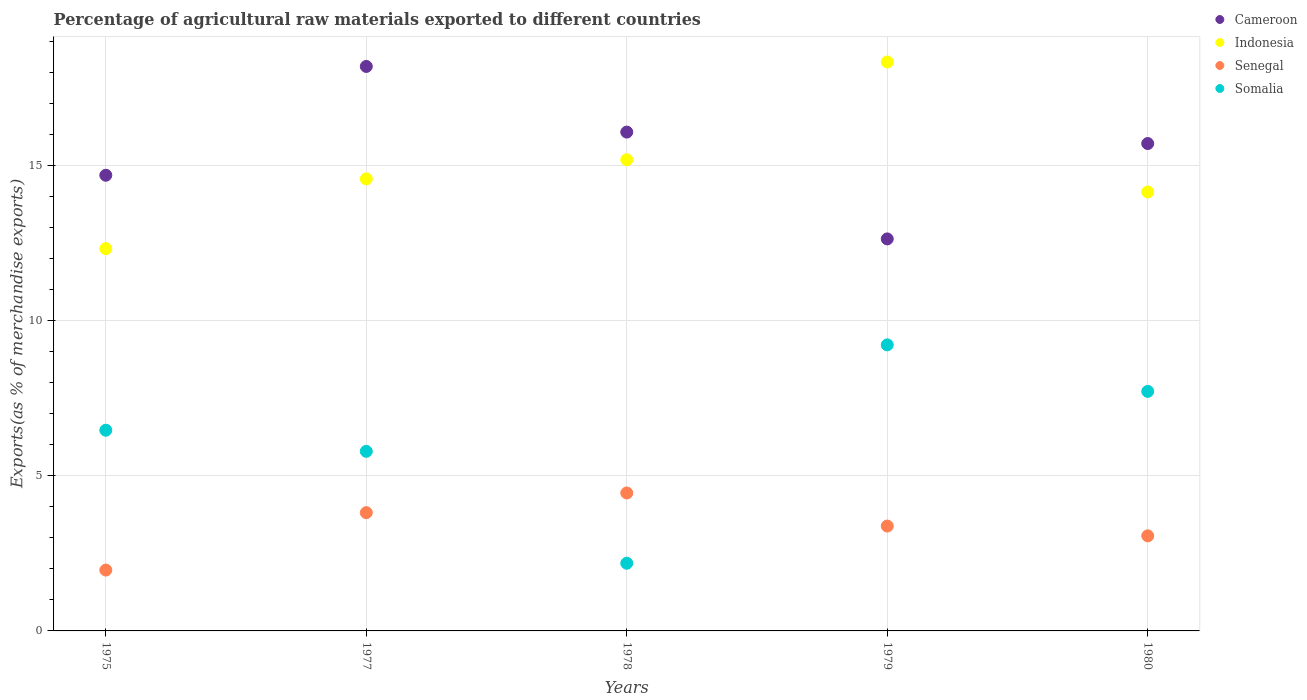What is the percentage of exports to different countries in Cameroon in 1979?
Make the answer very short. 12.63. Across all years, what is the maximum percentage of exports to different countries in Cameroon?
Offer a terse response. 18.18. Across all years, what is the minimum percentage of exports to different countries in Indonesia?
Offer a very short reply. 12.31. In which year was the percentage of exports to different countries in Cameroon maximum?
Your answer should be very brief. 1977. In which year was the percentage of exports to different countries in Indonesia minimum?
Keep it short and to the point. 1975. What is the total percentage of exports to different countries in Somalia in the graph?
Your answer should be compact. 31.36. What is the difference between the percentage of exports to different countries in Somalia in 1977 and that in 1980?
Your answer should be very brief. -1.93. What is the difference between the percentage of exports to different countries in Cameroon in 1979 and the percentage of exports to different countries in Indonesia in 1980?
Provide a short and direct response. -1.51. What is the average percentage of exports to different countries in Indonesia per year?
Provide a succinct answer. 14.9. In the year 1975, what is the difference between the percentage of exports to different countries in Cameroon and percentage of exports to different countries in Somalia?
Offer a very short reply. 8.21. What is the ratio of the percentage of exports to different countries in Senegal in 1977 to that in 1978?
Provide a succinct answer. 0.86. Is the difference between the percentage of exports to different countries in Cameroon in 1977 and 1978 greater than the difference between the percentage of exports to different countries in Somalia in 1977 and 1978?
Provide a short and direct response. No. What is the difference between the highest and the second highest percentage of exports to different countries in Somalia?
Keep it short and to the point. 1.5. What is the difference between the highest and the lowest percentage of exports to different countries in Somalia?
Offer a terse response. 7.03. In how many years, is the percentage of exports to different countries in Senegal greater than the average percentage of exports to different countries in Senegal taken over all years?
Ensure brevity in your answer.  3. Is the sum of the percentage of exports to different countries in Cameroon in 1975 and 1980 greater than the maximum percentage of exports to different countries in Senegal across all years?
Your answer should be compact. Yes. Is it the case that in every year, the sum of the percentage of exports to different countries in Somalia and percentage of exports to different countries in Cameroon  is greater than the sum of percentage of exports to different countries in Indonesia and percentage of exports to different countries in Senegal?
Provide a short and direct response. Yes. Does the percentage of exports to different countries in Senegal monotonically increase over the years?
Provide a short and direct response. No. Is the percentage of exports to different countries in Cameroon strictly less than the percentage of exports to different countries in Senegal over the years?
Your response must be concise. No. How many years are there in the graph?
Your answer should be compact. 5. Does the graph contain grids?
Offer a terse response. Yes. Where does the legend appear in the graph?
Make the answer very short. Top right. How are the legend labels stacked?
Your answer should be compact. Vertical. What is the title of the graph?
Ensure brevity in your answer.  Percentage of agricultural raw materials exported to different countries. What is the label or title of the X-axis?
Keep it short and to the point. Years. What is the label or title of the Y-axis?
Provide a succinct answer. Exports(as % of merchandise exports). What is the Exports(as % of merchandise exports) in Cameroon in 1975?
Provide a succinct answer. 14.68. What is the Exports(as % of merchandise exports) in Indonesia in 1975?
Give a very brief answer. 12.31. What is the Exports(as % of merchandise exports) in Senegal in 1975?
Provide a succinct answer. 1.96. What is the Exports(as % of merchandise exports) of Somalia in 1975?
Provide a short and direct response. 6.47. What is the Exports(as % of merchandise exports) in Cameroon in 1977?
Provide a short and direct response. 18.18. What is the Exports(as % of merchandise exports) of Indonesia in 1977?
Provide a succinct answer. 14.56. What is the Exports(as % of merchandise exports) in Senegal in 1977?
Keep it short and to the point. 3.81. What is the Exports(as % of merchandise exports) in Somalia in 1977?
Give a very brief answer. 5.78. What is the Exports(as % of merchandise exports) in Cameroon in 1978?
Provide a short and direct response. 16.07. What is the Exports(as % of merchandise exports) in Indonesia in 1978?
Keep it short and to the point. 15.18. What is the Exports(as % of merchandise exports) of Senegal in 1978?
Give a very brief answer. 4.44. What is the Exports(as % of merchandise exports) in Somalia in 1978?
Make the answer very short. 2.18. What is the Exports(as % of merchandise exports) in Cameroon in 1979?
Ensure brevity in your answer.  12.63. What is the Exports(as % of merchandise exports) in Indonesia in 1979?
Offer a very short reply. 18.33. What is the Exports(as % of merchandise exports) in Senegal in 1979?
Offer a terse response. 3.38. What is the Exports(as % of merchandise exports) in Somalia in 1979?
Offer a very short reply. 9.21. What is the Exports(as % of merchandise exports) of Cameroon in 1980?
Offer a terse response. 15.7. What is the Exports(as % of merchandise exports) of Indonesia in 1980?
Provide a succinct answer. 14.14. What is the Exports(as % of merchandise exports) in Senegal in 1980?
Provide a succinct answer. 3.06. What is the Exports(as % of merchandise exports) of Somalia in 1980?
Keep it short and to the point. 7.72. Across all years, what is the maximum Exports(as % of merchandise exports) of Cameroon?
Your response must be concise. 18.18. Across all years, what is the maximum Exports(as % of merchandise exports) of Indonesia?
Your response must be concise. 18.33. Across all years, what is the maximum Exports(as % of merchandise exports) of Senegal?
Provide a short and direct response. 4.44. Across all years, what is the maximum Exports(as % of merchandise exports) in Somalia?
Your answer should be very brief. 9.21. Across all years, what is the minimum Exports(as % of merchandise exports) of Cameroon?
Ensure brevity in your answer.  12.63. Across all years, what is the minimum Exports(as % of merchandise exports) in Indonesia?
Give a very brief answer. 12.31. Across all years, what is the minimum Exports(as % of merchandise exports) of Senegal?
Your response must be concise. 1.96. Across all years, what is the minimum Exports(as % of merchandise exports) of Somalia?
Give a very brief answer. 2.18. What is the total Exports(as % of merchandise exports) in Cameroon in the graph?
Make the answer very short. 77.25. What is the total Exports(as % of merchandise exports) of Indonesia in the graph?
Provide a short and direct response. 74.52. What is the total Exports(as % of merchandise exports) in Senegal in the graph?
Provide a short and direct response. 16.65. What is the total Exports(as % of merchandise exports) in Somalia in the graph?
Give a very brief answer. 31.36. What is the difference between the Exports(as % of merchandise exports) in Cameroon in 1975 and that in 1977?
Your answer should be compact. -3.5. What is the difference between the Exports(as % of merchandise exports) of Indonesia in 1975 and that in 1977?
Provide a short and direct response. -2.25. What is the difference between the Exports(as % of merchandise exports) of Senegal in 1975 and that in 1977?
Ensure brevity in your answer.  -1.85. What is the difference between the Exports(as % of merchandise exports) in Somalia in 1975 and that in 1977?
Ensure brevity in your answer.  0.68. What is the difference between the Exports(as % of merchandise exports) in Cameroon in 1975 and that in 1978?
Provide a succinct answer. -1.39. What is the difference between the Exports(as % of merchandise exports) of Indonesia in 1975 and that in 1978?
Ensure brevity in your answer.  -2.86. What is the difference between the Exports(as % of merchandise exports) in Senegal in 1975 and that in 1978?
Offer a very short reply. -2.48. What is the difference between the Exports(as % of merchandise exports) in Somalia in 1975 and that in 1978?
Your answer should be compact. 4.29. What is the difference between the Exports(as % of merchandise exports) of Cameroon in 1975 and that in 1979?
Keep it short and to the point. 2.05. What is the difference between the Exports(as % of merchandise exports) in Indonesia in 1975 and that in 1979?
Give a very brief answer. -6.01. What is the difference between the Exports(as % of merchandise exports) of Senegal in 1975 and that in 1979?
Your answer should be compact. -1.42. What is the difference between the Exports(as % of merchandise exports) of Somalia in 1975 and that in 1979?
Make the answer very short. -2.75. What is the difference between the Exports(as % of merchandise exports) in Cameroon in 1975 and that in 1980?
Offer a terse response. -1.02. What is the difference between the Exports(as % of merchandise exports) of Indonesia in 1975 and that in 1980?
Your response must be concise. -1.83. What is the difference between the Exports(as % of merchandise exports) of Senegal in 1975 and that in 1980?
Keep it short and to the point. -1.1. What is the difference between the Exports(as % of merchandise exports) of Somalia in 1975 and that in 1980?
Provide a succinct answer. -1.25. What is the difference between the Exports(as % of merchandise exports) of Cameroon in 1977 and that in 1978?
Ensure brevity in your answer.  2.11. What is the difference between the Exports(as % of merchandise exports) in Indonesia in 1977 and that in 1978?
Your response must be concise. -0.62. What is the difference between the Exports(as % of merchandise exports) in Senegal in 1977 and that in 1978?
Ensure brevity in your answer.  -0.63. What is the difference between the Exports(as % of merchandise exports) of Somalia in 1977 and that in 1978?
Ensure brevity in your answer.  3.6. What is the difference between the Exports(as % of merchandise exports) of Cameroon in 1977 and that in 1979?
Your answer should be very brief. 5.56. What is the difference between the Exports(as % of merchandise exports) in Indonesia in 1977 and that in 1979?
Provide a succinct answer. -3.77. What is the difference between the Exports(as % of merchandise exports) in Senegal in 1977 and that in 1979?
Keep it short and to the point. 0.43. What is the difference between the Exports(as % of merchandise exports) of Somalia in 1977 and that in 1979?
Offer a terse response. -3.43. What is the difference between the Exports(as % of merchandise exports) in Cameroon in 1977 and that in 1980?
Your response must be concise. 2.48. What is the difference between the Exports(as % of merchandise exports) of Indonesia in 1977 and that in 1980?
Ensure brevity in your answer.  0.42. What is the difference between the Exports(as % of merchandise exports) of Senegal in 1977 and that in 1980?
Offer a terse response. 0.75. What is the difference between the Exports(as % of merchandise exports) in Somalia in 1977 and that in 1980?
Provide a short and direct response. -1.93. What is the difference between the Exports(as % of merchandise exports) of Cameroon in 1978 and that in 1979?
Make the answer very short. 3.44. What is the difference between the Exports(as % of merchandise exports) of Indonesia in 1978 and that in 1979?
Ensure brevity in your answer.  -3.15. What is the difference between the Exports(as % of merchandise exports) in Senegal in 1978 and that in 1979?
Offer a terse response. 1.07. What is the difference between the Exports(as % of merchandise exports) of Somalia in 1978 and that in 1979?
Offer a terse response. -7.03. What is the difference between the Exports(as % of merchandise exports) of Cameroon in 1978 and that in 1980?
Your answer should be compact. 0.37. What is the difference between the Exports(as % of merchandise exports) in Indonesia in 1978 and that in 1980?
Provide a short and direct response. 1.04. What is the difference between the Exports(as % of merchandise exports) in Senegal in 1978 and that in 1980?
Provide a short and direct response. 1.38. What is the difference between the Exports(as % of merchandise exports) of Somalia in 1978 and that in 1980?
Provide a succinct answer. -5.54. What is the difference between the Exports(as % of merchandise exports) of Cameroon in 1979 and that in 1980?
Give a very brief answer. -3.07. What is the difference between the Exports(as % of merchandise exports) of Indonesia in 1979 and that in 1980?
Your answer should be compact. 4.19. What is the difference between the Exports(as % of merchandise exports) of Senegal in 1979 and that in 1980?
Your response must be concise. 0.32. What is the difference between the Exports(as % of merchandise exports) of Somalia in 1979 and that in 1980?
Ensure brevity in your answer.  1.5. What is the difference between the Exports(as % of merchandise exports) of Cameroon in 1975 and the Exports(as % of merchandise exports) of Indonesia in 1977?
Offer a very short reply. 0.12. What is the difference between the Exports(as % of merchandise exports) in Cameroon in 1975 and the Exports(as % of merchandise exports) in Senegal in 1977?
Provide a short and direct response. 10.87. What is the difference between the Exports(as % of merchandise exports) in Cameroon in 1975 and the Exports(as % of merchandise exports) in Somalia in 1977?
Give a very brief answer. 8.89. What is the difference between the Exports(as % of merchandise exports) of Indonesia in 1975 and the Exports(as % of merchandise exports) of Senegal in 1977?
Your response must be concise. 8.5. What is the difference between the Exports(as % of merchandise exports) of Indonesia in 1975 and the Exports(as % of merchandise exports) of Somalia in 1977?
Keep it short and to the point. 6.53. What is the difference between the Exports(as % of merchandise exports) in Senegal in 1975 and the Exports(as % of merchandise exports) in Somalia in 1977?
Ensure brevity in your answer.  -3.82. What is the difference between the Exports(as % of merchandise exports) of Cameroon in 1975 and the Exports(as % of merchandise exports) of Indonesia in 1978?
Provide a short and direct response. -0.5. What is the difference between the Exports(as % of merchandise exports) of Cameroon in 1975 and the Exports(as % of merchandise exports) of Senegal in 1978?
Provide a short and direct response. 10.23. What is the difference between the Exports(as % of merchandise exports) in Cameroon in 1975 and the Exports(as % of merchandise exports) in Somalia in 1978?
Offer a terse response. 12.5. What is the difference between the Exports(as % of merchandise exports) in Indonesia in 1975 and the Exports(as % of merchandise exports) in Senegal in 1978?
Provide a short and direct response. 7.87. What is the difference between the Exports(as % of merchandise exports) in Indonesia in 1975 and the Exports(as % of merchandise exports) in Somalia in 1978?
Offer a terse response. 10.13. What is the difference between the Exports(as % of merchandise exports) of Senegal in 1975 and the Exports(as % of merchandise exports) of Somalia in 1978?
Provide a succinct answer. -0.22. What is the difference between the Exports(as % of merchandise exports) in Cameroon in 1975 and the Exports(as % of merchandise exports) in Indonesia in 1979?
Ensure brevity in your answer.  -3.65. What is the difference between the Exports(as % of merchandise exports) of Cameroon in 1975 and the Exports(as % of merchandise exports) of Senegal in 1979?
Provide a short and direct response. 11.3. What is the difference between the Exports(as % of merchandise exports) of Cameroon in 1975 and the Exports(as % of merchandise exports) of Somalia in 1979?
Make the answer very short. 5.46. What is the difference between the Exports(as % of merchandise exports) in Indonesia in 1975 and the Exports(as % of merchandise exports) in Senegal in 1979?
Make the answer very short. 8.94. What is the difference between the Exports(as % of merchandise exports) in Indonesia in 1975 and the Exports(as % of merchandise exports) in Somalia in 1979?
Your response must be concise. 3.1. What is the difference between the Exports(as % of merchandise exports) in Senegal in 1975 and the Exports(as % of merchandise exports) in Somalia in 1979?
Keep it short and to the point. -7.25. What is the difference between the Exports(as % of merchandise exports) in Cameroon in 1975 and the Exports(as % of merchandise exports) in Indonesia in 1980?
Provide a short and direct response. 0.54. What is the difference between the Exports(as % of merchandise exports) of Cameroon in 1975 and the Exports(as % of merchandise exports) of Senegal in 1980?
Offer a very short reply. 11.62. What is the difference between the Exports(as % of merchandise exports) of Cameroon in 1975 and the Exports(as % of merchandise exports) of Somalia in 1980?
Offer a terse response. 6.96. What is the difference between the Exports(as % of merchandise exports) in Indonesia in 1975 and the Exports(as % of merchandise exports) in Senegal in 1980?
Provide a short and direct response. 9.25. What is the difference between the Exports(as % of merchandise exports) in Indonesia in 1975 and the Exports(as % of merchandise exports) in Somalia in 1980?
Offer a terse response. 4.6. What is the difference between the Exports(as % of merchandise exports) in Senegal in 1975 and the Exports(as % of merchandise exports) in Somalia in 1980?
Give a very brief answer. -5.76. What is the difference between the Exports(as % of merchandise exports) of Cameroon in 1977 and the Exports(as % of merchandise exports) of Indonesia in 1978?
Make the answer very short. 3.01. What is the difference between the Exports(as % of merchandise exports) in Cameroon in 1977 and the Exports(as % of merchandise exports) in Senegal in 1978?
Make the answer very short. 13.74. What is the difference between the Exports(as % of merchandise exports) in Cameroon in 1977 and the Exports(as % of merchandise exports) in Somalia in 1978?
Your answer should be compact. 16. What is the difference between the Exports(as % of merchandise exports) of Indonesia in 1977 and the Exports(as % of merchandise exports) of Senegal in 1978?
Provide a succinct answer. 10.12. What is the difference between the Exports(as % of merchandise exports) of Indonesia in 1977 and the Exports(as % of merchandise exports) of Somalia in 1978?
Your response must be concise. 12.38. What is the difference between the Exports(as % of merchandise exports) in Senegal in 1977 and the Exports(as % of merchandise exports) in Somalia in 1978?
Keep it short and to the point. 1.63. What is the difference between the Exports(as % of merchandise exports) of Cameroon in 1977 and the Exports(as % of merchandise exports) of Indonesia in 1979?
Offer a terse response. -0.14. What is the difference between the Exports(as % of merchandise exports) of Cameroon in 1977 and the Exports(as % of merchandise exports) of Senegal in 1979?
Make the answer very short. 14.8. What is the difference between the Exports(as % of merchandise exports) of Cameroon in 1977 and the Exports(as % of merchandise exports) of Somalia in 1979?
Make the answer very short. 8.97. What is the difference between the Exports(as % of merchandise exports) of Indonesia in 1977 and the Exports(as % of merchandise exports) of Senegal in 1979?
Provide a succinct answer. 11.18. What is the difference between the Exports(as % of merchandise exports) in Indonesia in 1977 and the Exports(as % of merchandise exports) in Somalia in 1979?
Offer a terse response. 5.35. What is the difference between the Exports(as % of merchandise exports) of Senegal in 1977 and the Exports(as % of merchandise exports) of Somalia in 1979?
Provide a succinct answer. -5.4. What is the difference between the Exports(as % of merchandise exports) in Cameroon in 1977 and the Exports(as % of merchandise exports) in Indonesia in 1980?
Offer a very short reply. 4.04. What is the difference between the Exports(as % of merchandise exports) of Cameroon in 1977 and the Exports(as % of merchandise exports) of Senegal in 1980?
Offer a terse response. 15.12. What is the difference between the Exports(as % of merchandise exports) of Cameroon in 1977 and the Exports(as % of merchandise exports) of Somalia in 1980?
Provide a short and direct response. 10.47. What is the difference between the Exports(as % of merchandise exports) in Indonesia in 1977 and the Exports(as % of merchandise exports) in Senegal in 1980?
Ensure brevity in your answer.  11.5. What is the difference between the Exports(as % of merchandise exports) in Indonesia in 1977 and the Exports(as % of merchandise exports) in Somalia in 1980?
Give a very brief answer. 6.85. What is the difference between the Exports(as % of merchandise exports) in Senegal in 1977 and the Exports(as % of merchandise exports) in Somalia in 1980?
Keep it short and to the point. -3.91. What is the difference between the Exports(as % of merchandise exports) in Cameroon in 1978 and the Exports(as % of merchandise exports) in Indonesia in 1979?
Your answer should be very brief. -2.26. What is the difference between the Exports(as % of merchandise exports) in Cameroon in 1978 and the Exports(as % of merchandise exports) in Senegal in 1979?
Ensure brevity in your answer.  12.69. What is the difference between the Exports(as % of merchandise exports) in Cameroon in 1978 and the Exports(as % of merchandise exports) in Somalia in 1979?
Your response must be concise. 6.85. What is the difference between the Exports(as % of merchandise exports) of Indonesia in 1978 and the Exports(as % of merchandise exports) of Senegal in 1979?
Offer a very short reply. 11.8. What is the difference between the Exports(as % of merchandise exports) in Indonesia in 1978 and the Exports(as % of merchandise exports) in Somalia in 1979?
Give a very brief answer. 5.96. What is the difference between the Exports(as % of merchandise exports) in Senegal in 1978 and the Exports(as % of merchandise exports) in Somalia in 1979?
Your answer should be very brief. -4.77. What is the difference between the Exports(as % of merchandise exports) in Cameroon in 1978 and the Exports(as % of merchandise exports) in Indonesia in 1980?
Offer a very short reply. 1.93. What is the difference between the Exports(as % of merchandise exports) of Cameroon in 1978 and the Exports(as % of merchandise exports) of Senegal in 1980?
Provide a short and direct response. 13.01. What is the difference between the Exports(as % of merchandise exports) of Cameroon in 1978 and the Exports(as % of merchandise exports) of Somalia in 1980?
Ensure brevity in your answer.  8.35. What is the difference between the Exports(as % of merchandise exports) in Indonesia in 1978 and the Exports(as % of merchandise exports) in Senegal in 1980?
Provide a short and direct response. 12.11. What is the difference between the Exports(as % of merchandise exports) in Indonesia in 1978 and the Exports(as % of merchandise exports) in Somalia in 1980?
Keep it short and to the point. 7.46. What is the difference between the Exports(as % of merchandise exports) of Senegal in 1978 and the Exports(as % of merchandise exports) of Somalia in 1980?
Keep it short and to the point. -3.27. What is the difference between the Exports(as % of merchandise exports) of Cameroon in 1979 and the Exports(as % of merchandise exports) of Indonesia in 1980?
Ensure brevity in your answer.  -1.51. What is the difference between the Exports(as % of merchandise exports) of Cameroon in 1979 and the Exports(as % of merchandise exports) of Senegal in 1980?
Offer a terse response. 9.56. What is the difference between the Exports(as % of merchandise exports) in Cameroon in 1979 and the Exports(as % of merchandise exports) in Somalia in 1980?
Keep it short and to the point. 4.91. What is the difference between the Exports(as % of merchandise exports) in Indonesia in 1979 and the Exports(as % of merchandise exports) in Senegal in 1980?
Your response must be concise. 15.26. What is the difference between the Exports(as % of merchandise exports) in Indonesia in 1979 and the Exports(as % of merchandise exports) in Somalia in 1980?
Make the answer very short. 10.61. What is the difference between the Exports(as % of merchandise exports) in Senegal in 1979 and the Exports(as % of merchandise exports) in Somalia in 1980?
Give a very brief answer. -4.34. What is the average Exports(as % of merchandise exports) of Cameroon per year?
Keep it short and to the point. 15.45. What is the average Exports(as % of merchandise exports) of Indonesia per year?
Your response must be concise. 14.9. What is the average Exports(as % of merchandise exports) in Senegal per year?
Your answer should be very brief. 3.33. What is the average Exports(as % of merchandise exports) in Somalia per year?
Your answer should be very brief. 6.27. In the year 1975, what is the difference between the Exports(as % of merchandise exports) of Cameroon and Exports(as % of merchandise exports) of Indonesia?
Ensure brevity in your answer.  2.36. In the year 1975, what is the difference between the Exports(as % of merchandise exports) of Cameroon and Exports(as % of merchandise exports) of Senegal?
Provide a short and direct response. 12.72. In the year 1975, what is the difference between the Exports(as % of merchandise exports) in Cameroon and Exports(as % of merchandise exports) in Somalia?
Provide a succinct answer. 8.21. In the year 1975, what is the difference between the Exports(as % of merchandise exports) in Indonesia and Exports(as % of merchandise exports) in Senegal?
Provide a succinct answer. 10.35. In the year 1975, what is the difference between the Exports(as % of merchandise exports) of Indonesia and Exports(as % of merchandise exports) of Somalia?
Offer a very short reply. 5.85. In the year 1975, what is the difference between the Exports(as % of merchandise exports) of Senegal and Exports(as % of merchandise exports) of Somalia?
Your response must be concise. -4.51. In the year 1977, what is the difference between the Exports(as % of merchandise exports) of Cameroon and Exports(as % of merchandise exports) of Indonesia?
Give a very brief answer. 3.62. In the year 1977, what is the difference between the Exports(as % of merchandise exports) in Cameroon and Exports(as % of merchandise exports) in Senegal?
Offer a terse response. 14.37. In the year 1977, what is the difference between the Exports(as % of merchandise exports) in Cameroon and Exports(as % of merchandise exports) in Somalia?
Provide a short and direct response. 12.4. In the year 1977, what is the difference between the Exports(as % of merchandise exports) of Indonesia and Exports(as % of merchandise exports) of Senegal?
Provide a short and direct response. 10.75. In the year 1977, what is the difference between the Exports(as % of merchandise exports) in Indonesia and Exports(as % of merchandise exports) in Somalia?
Keep it short and to the point. 8.78. In the year 1977, what is the difference between the Exports(as % of merchandise exports) in Senegal and Exports(as % of merchandise exports) in Somalia?
Make the answer very short. -1.98. In the year 1978, what is the difference between the Exports(as % of merchandise exports) of Cameroon and Exports(as % of merchandise exports) of Indonesia?
Offer a very short reply. 0.89. In the year 1978, what is the difference between the Exports(as % of merchandise exports) in Cameroon and Exports(as % of merchandise exports) in Senegal?
Offer a terse response. 11.62. In the year 1978, what is the difference between the Exports(as % of merchandise exports) of Cameroon and Exports(as % of merchandise exports) of Somalia?
Offer a terse response. 13.89. In the year 1978, what is the difference between the Exports(as % of merchandise exports) in Indonesia and Exports(as % of merchandise exports) in Senegal?
Keep it short and to the point. 10.73. In the year 1978, what is the difference between the Exports(as % of merchandise exports) of Indonesia and Exports(as % of merchandise exports) of Somalia?
Your answer should be compact. 13. In the year 1978, what is the difference between the Exports(as % of merchandise exports) of Senegal and Exports(as % of merchandise exports) of Somalia?
Make the answer very short. 2.26. In the year 1979, what is the difference between the Exports(as % of merchandise exports) in Cameroon and Exports(as % of merchandise exports) in Indonesia?
Keep it short and to the point. -5.7. In the year 1979, what is the difference between the Exports(as % of merchandise exports) in Cameroon and Exports(as % of merchandise exports) in Senegal?
Ensure brevity in your answer.  9.25. In the year 1979, what is the difference between the Exports(as % of merchandise exports) in Cameroon and Exports(as % of merchandise exports) in Somalia?
Ensure brevity in your answer.  3.41. In the year 1979, what is the difference between the Exports(as % of merchandise exports) of Indonesia and Exports(as % of merchandise exports) of Senegal?
Offer a very short reply. 14.95. In the year 1979, what is the difference between the Exports(as % of merchandise exports) in Indonesia and Exports(as % of merchandise exports) in Somalia?
Offer a very short reply. 9.11. In the year 1979, what is the difference between the Exports(as % of merchandise exports) in Senegal and Exports(as % of merchandise exports) in Somalia?
Keep it short and to the point. -5.84. In the year 1980, what is the difference between the Exports(as % of merchandise exports) in Cameroon and Exports(as % of merchandise exports) in Indonesia?
Your answer should be compact. 1.56. In the year 1980, what is the difference between the Exports(as % of merchandise exports) of Cameroon and Exports(as % of merchandise exports) of Senegal?
Make the answer very short. 12.64. In the year 1980, what is the difference between the Exports(as % of merchandise exports) in Cameroon and Exports(as % of merchandise exports) in Somalia?
Provide a short and direct response. 7.98. In the year 1980, what is the difference between the Exports(as % of merchandise exports) in Indonesia and Exports(as % of merchandise exports) in Senegal?
Provide a succinct answer. 11.08. In the year 1980, what is the difference between the Exports(as % of merchandise exports) in Indonesia and Exports(as % of merchandise exports) in Somalia?
Offer a very short reply. 6.42. In the year 1980, what is the difference between the Exports(as % of merchandise exports) in Senegal and Exports(as % of merchandise exports) in Somalia?
Ensure brevity in your answer.  -4.65. What is the ratio of the Exports(as % of merchandise exports) of Cameroon in 1975 to that in 1977?
Your answer should be compact. 0.81. What is the ratio of the Exports(as % of merchandise exports) of Indonesia in 1975 to that in 1977?
Offer a terse response. 0.85. What is the ratio of the Exports(as % of merchandise exports) in Senegal in 1975 to that in 1977?
Your response must be concise. 0.51. What is the ratio of the Exports(as % of merchandise exports) in Somalia in 1975 to that in 1977?
Ensure brevity in your answer.  1.12. What is the ratio of the Exports(as % of merchandise exports) of Cameroon in 1975 to that in 1978?
Make the answer very short. 0.91. What is the ratio of the Exports(as % of merchandise exports) in Indonesia in 1975 to that in 1978?
Keep it short and to the point. 0.81. What is the ratio of the Exports(as % of merchandise exports) in Senegal in 1975 to that in 1978?
Ensure brevity in your answer.  0.44. What is the ratio of the Exports(as % of merchandise exports) in Somalia in 1975 to that in 1978?
Your response must be concise. 2.97. What is the ratio of the Exports(as % of merchandise exports) in Cameroon in 1975 to that in 1979?
Ensure brevity in your answer.  1.16. What is the ratio of the Exports(as % of merchandise exports) of Indonesia in 1975 to that in 1979?
Your response must be concise. 0.67. What is the ratio of the Exports(as % of merchandise exports) of Senegal in 1975 to that in 1979?
Provide a succinct answer. 0.58. What is the ratio of the Exports(as % of merchandise exports) in Somalia in 1975 to that in 1979?
Give a very brief answer. 0.7. What is the ratio of the Exports(as % of merchandise exports) of Cameroon in 1975 to that in 1980?
Make the answer very short. 0.93. What is the ratio of the Exports(as % of merchandise exports) in Indonesia in 1975 to that in 1980?
Provide a short and direct response. 0.87. What is the ratio of the Exports(as % of merchandise exports) of Senegal in 1975 to that in 1980?
Provide a short and direct response. 0.64. What is the ratio of the Exports(as % of merchandise exports) in Somalia in 1975 to that in 1980?
Keep it short and to the point. 0.84. What is the ratio of the Exports(as % of merchandise exports) of Cameroon in 1977 to that in 1978?
Your answer should be very brief. 1.13. What is the ratio of the Exports(as % of merchandise exports) of Indonesia in 1977 to that in 1978?
Keep it short and to the point. 0.96. What is the ratio of the Exports(as % of merchandise exports) in Senegal in 1977 to that in 1978?
Keep it short and to the point. 0.86. What is the ratio of the Exports(as % of merchandise exports) in Somalia in 1977 to that in 1978?
Give a very brief answer. 2.65. What is the ratio of the Exports(as % of merchandise exports) of Cameroon in 1977 to that in 1979?
Provide a succinct answer. 1.44. What is the ratio of the Exports(as % of merchandise exports) in Indonesia in 1977 to that in 1979?
Give a very brief answer. 0.79. What is the ratio of the Exports(as % of merchandise exports) in Senegal in 1977 to that in 1979?
Ensure brevity in your answer.  1.13. What is the ratio of the Exports(as % of merchandise exports) of Somalia in 1977 to that in 1979?
Make the answer very short. 0.63. What is the ratio of the Exports(as % of merchandise exports) in Cameroon in 1977 to that in 1980?
Keep it short and to the point. 1.16. What is the ratio of the Exports(as % of merchandise exports) in Indonesia in 1977 to that in 1980?
Make the answer very short. 1.03. What is the ratio of the Exports(as % of merchandise exports) in Senegal in 1977 to that in 1980?
Keep it short and to the point. 1.24. What is the ratio of the Exports(as % of merchandise exports) in Somalia in 1977 to that in 1980?
Keep it short and to the point. 0.75. What is the ratio of the Exports(as % of merchandise exports) in Cameroon in 1978 to that in 1979?
Make the answer very short. 1.27. What is the ratio of the Exports(as % of merchandise exports) of Indonesia in 1978 to that in 1979?
Your answer should be very brief. 0.83. What is the ratio of the Exports(as % of merchandise exports) in Senegal in 1978 to that in 1979?
Make the answer very short. 1.32. What is the ratio of the Exports(as % of merchandise exports) in Somalia in 1978 to that in 1979?
Your answer should be very brief. 0.24. What is the ratio of the Exports(as % of merchandise exports) of Cameroon in 1978 to that in 1980?
Make the answer very short. 1.02. What is the ratio of the Exports(as % of merchandise exports) of Indonesia in 1978 to that in 1980?
Provide a succinct answer. 1.07. What is the ratio of the Exports(as % of merchandise exports) in Senegal in 1978 to that in 1980?
Keep it short and to the point. 1.45. What is the ratio of the Exports(as % of merchandise exports) of Somalia in 1978 to that in 1980?
Provide a succinct answer. 0.28. What is the ratio of the Exports(as % of merchandise exports) of Cameroon in 1979 to that in 1980?
Your response must be concise. 0.8. What is the ratio of the Exports(as % of merchandise exports) of Indonesia in 1979 to that in 1980?
Give a very brief answer. 1.3. What is the ratio of the Exports(as % of merchandise exports) in Senegal in 1979 to that in 1980?
Give a very brief answer. 1.1. What is the ratio of the Exports(as % of merchandise exports) in Somalia in 1979 to that in 1980?
Provide a short and direct response. 1.19. What is the difference between the highest and the second highest Exports(as % of merchandise exports) in Cameroon?
Your response must be concise. 2.11. What is the difference between the highest and the second highest Exports(as % of merchandise exports) in Indonesia?
Your answer should be compact. 3.15. What is the difference between the highest and the second highest Exports(as % of merchandise exports) of Senegal?
Give a very brief answer. 0.63. What is the difference between the highest and the second highest Exports(as % of merchandise exports) of Somalia?
Provide a short and direct response. 1.5. What is the difference between the highest and the lowest Exports(as % of merchandise exports) of Cameroon?
Offer a terse response. 5.56. What is the difference between the highest and the lowest Exports(as % of merchandise exports) of Indonesia?
Ensure brevity in your answer.  6.01. What is the difference between the highest and the lowest Exports(as % of merchandise exports) in Senegal?
Your answer should be compact. 2.48. What is the difference between the highest and the lowest Exports(as % of merchandise exports) of Somalia?
Ensure brevity in your answer.  7.03. 